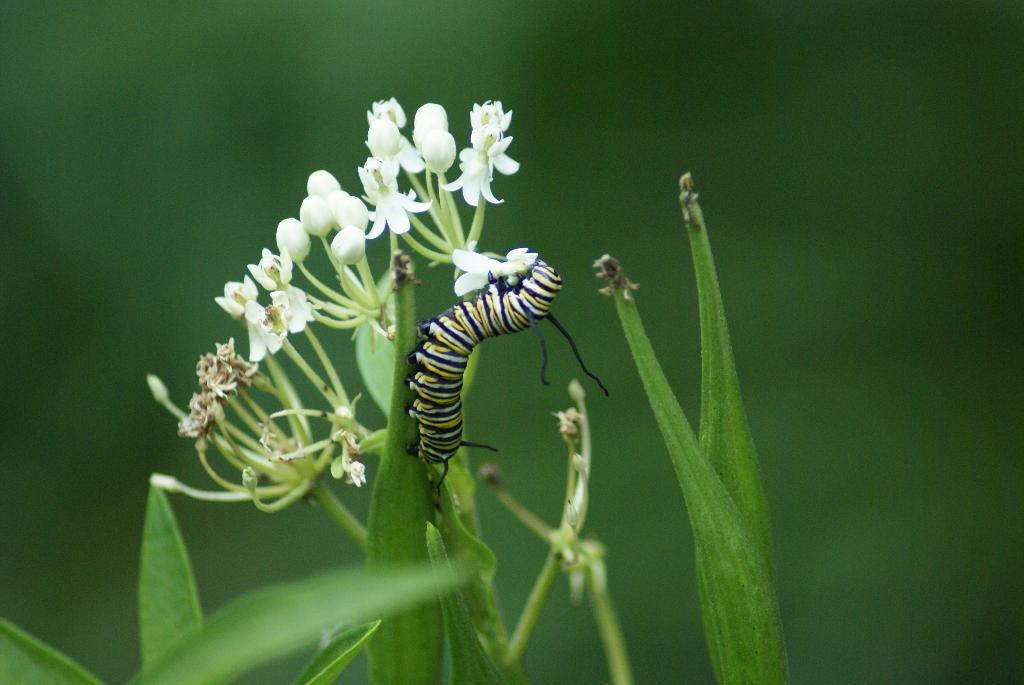What is the main subject of the image? There is a caterpillar on a leaf in the image. What other elements can be seen in the image? There are flowers and plants in the image. How would you describe the background of the image? The background of the image is blurry. What type of cemetery can be seen in the background of the image? There is no cemetery present in the image; the background is blurry and does not show any specific location or structure. 